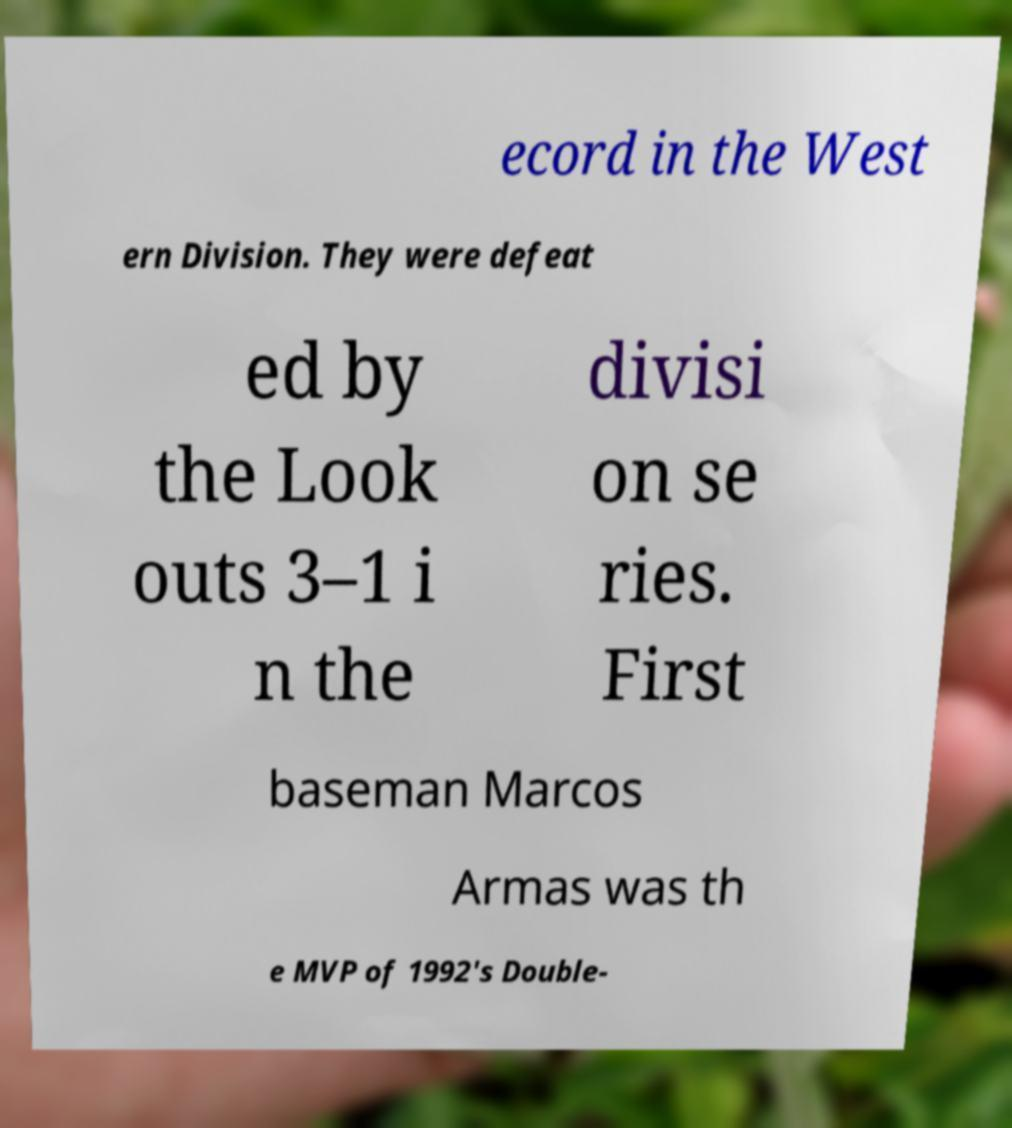What messages or text are displayed in this image? I need them in a readable, typed format. ecord in the West ern Division. They were defeat ed by the Look outs 3–1 i n the divisi on se ries. First baseman Marcos Armas was th e MVP of 1992's Double- 